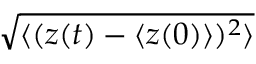Convert formula to latex. <formula><loc_0><loc_0><loc_500><loc_500>\sqrt { \langle ( z ( t ) - \langle z ( 0 ) \rangle ) ^ { 2 } \rangle }</formula> 